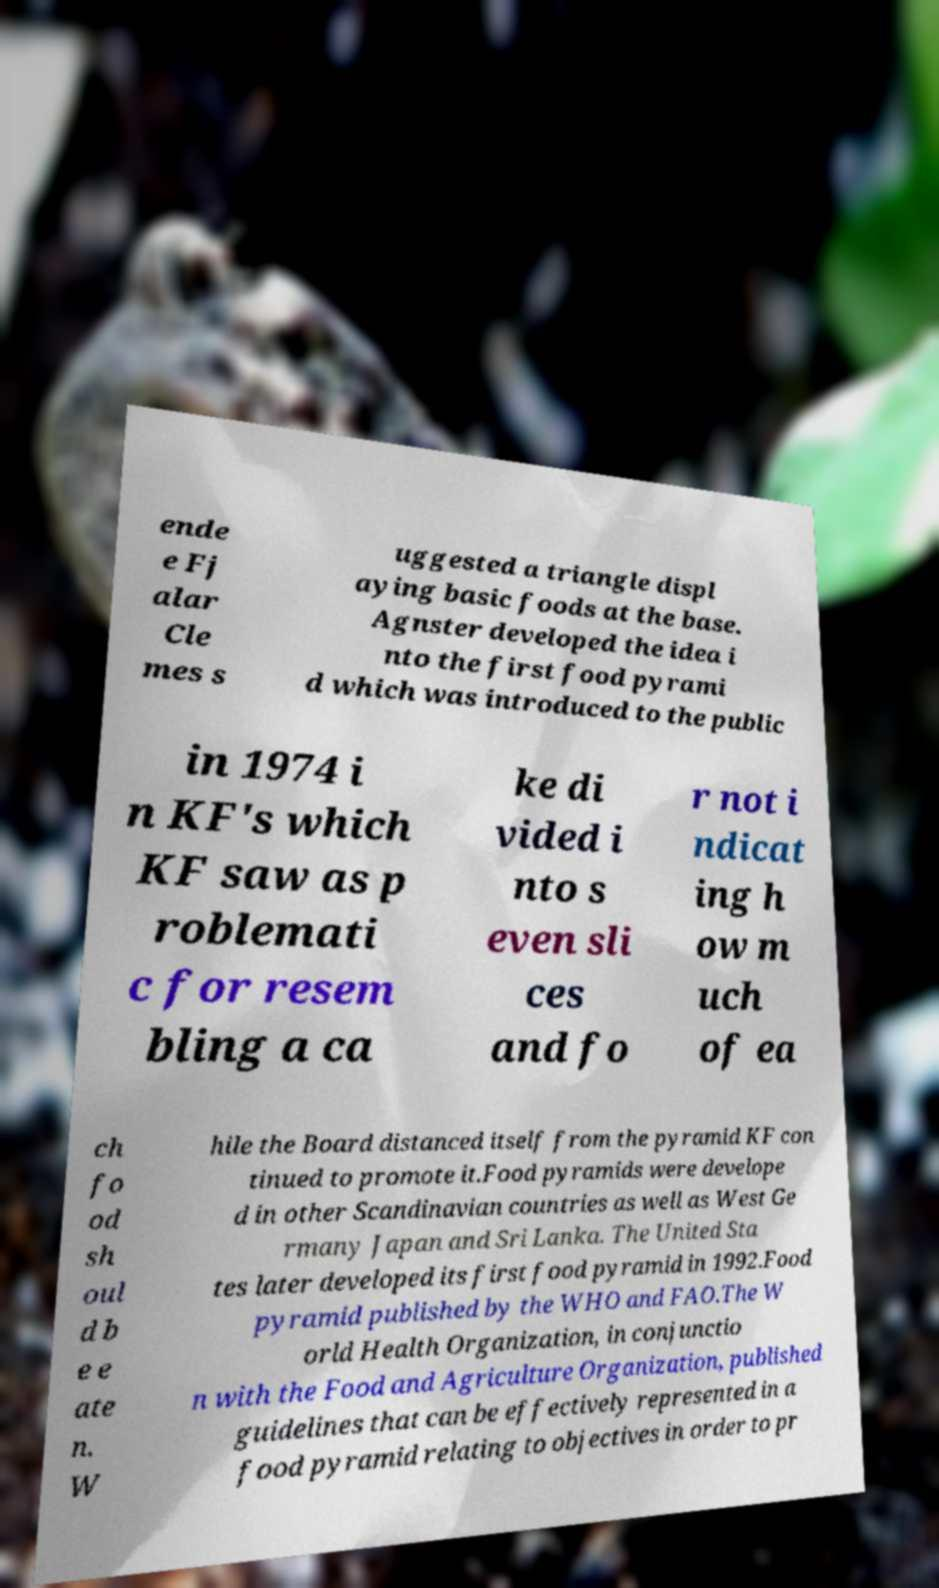I need the written content from this picture converted into text. Can you do that? ende e Fj alar Cle mes s uggested a triangle displ aying basic foods at the base. Agnster developed the idea i nto the first food pyrami d which was introduced to the public in 1974 i n KF's which KF saw as p roblemati c for resem bling a ca ke di vided i nto s even sli ces and fo r not i ndicat ing h ow m uch of ea ch fo od sh oul d b e e ate n. W hile the Board distanced itself from the pyramid KF con tinued to promote it.Food pyramids were develope d in other Scandinavian countries as well as West Ge rmany Japan and Sri Lanka. The United Sta tes later developed its first food pyramid in 1992.Food pyramid published by the WHO and FAO.The W orld Health Organization, in conjunctio n with the Food and Agriculture Organization, published guidelines that can be effectively represented in a food pyramid relating to objectives in order to pr 